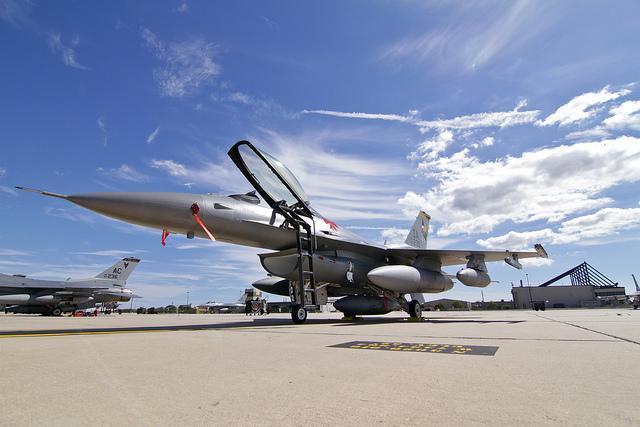How many planes are in the picture?
Give a very brief answer. 2. How many airplanes are there?
Give a very brief answer. 2. 